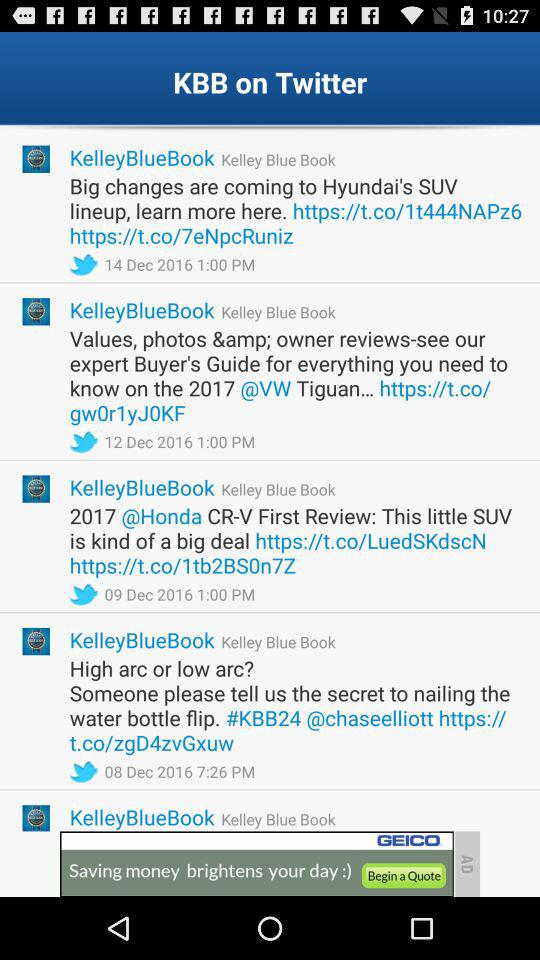In which category of price $28,930 falls? The category of price $28,930 falls is "MSRP". 